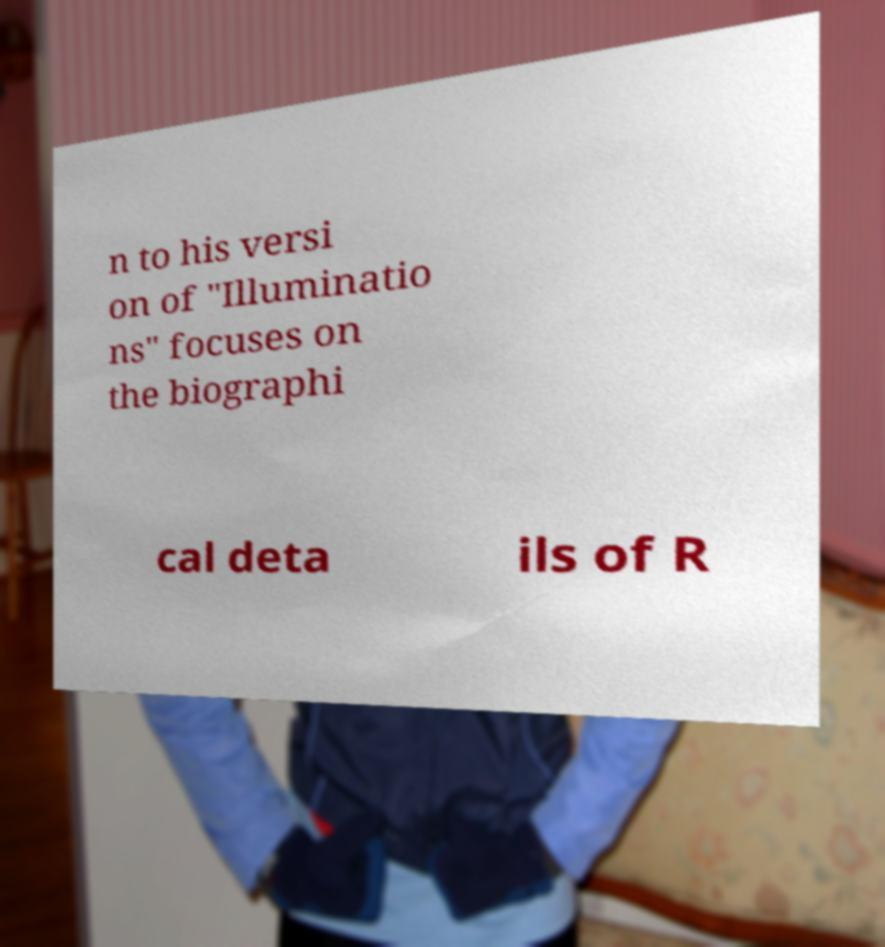Please identify and transcribe the text found in this image. n to his versi on of "Illuminatio ns" focuses on the biographi cal deta ils of R 